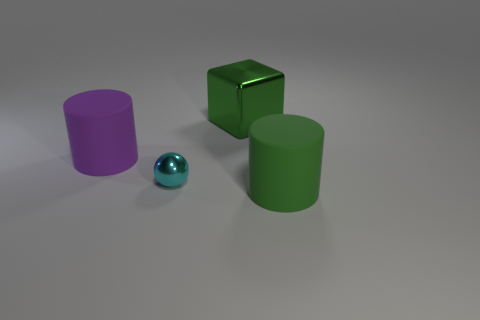Subtract all green cylinders. How many cylinders are left? 1 Subtract 0 red cylinders. How many objects are left? 4 Subtract all cubes. How many objects are left? 3 Subtract 1 blocks. How many blocks are left? 0 Subtract all blue balls. Subtract all red cylinders. How many balls are left? 1 Subtract all purple cubes. How many purple cylinders are left? 1 Subtract all green matte things. Subtract all large gray shiny spheres. How many objects are left? 3 Add 3 big blocks. How many big blocks are left? 4 Add 1 big green cubes. How many big green cubes exist? 2 Add 1 cyan things. How many objects exist? 5 